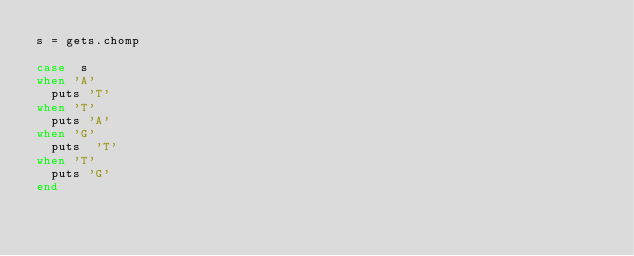Convert code to text. <code><loc_0><loc_0><loc_500><loc_500><_Ruby_>s = gets.chomp

case  s
when 'A'
  puts 'T'
when 'T'
  puts 'A'
when 'G'
  puts  'T'
when 'T'
  puts 'G'
end</code> 